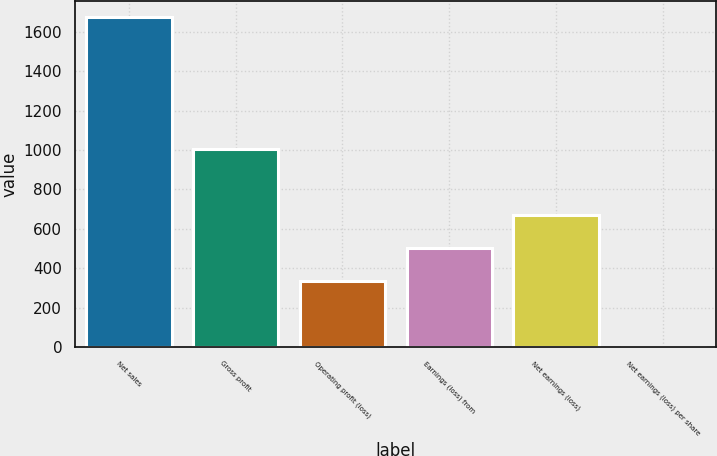Convert chart to OTSL. <chart><loc_0><loc_0><loc_500><loc_500><bar_chart><fcel>Net sales<fcel>Gross profit<fcel>Operating profit (loss)<fcel>Earnings (loss) from<fcel>Net earnings (loss)<fcel>Net earnings (loss) per share<nl><fcel>1675<fcel>1005.54<fcel>336.1<fcel>503.46<fcel>670.82<fcel>1.38<nl></chart> 